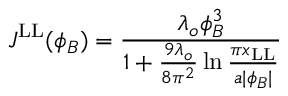<formula> <loc_0><loc_0><loc_500><loc_500>J ^ { L L } ( \phi _ { B } ) = { \frac { \lambda _ { o } \phi _ { B } ^ { 3 } } { 1 + { \frac { 9 \lambda _ { o } } { 8 \pi ^ { 2 } } } \ln { \frac { \pi x _ { L L } } { a | \phi _ { B } | } } } }</formula> 